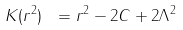Convert formula to latex. <formula><loc_0><loc_0><loc_500><loc_500>K ( r ^ { 2 } ) \ = r ^ { 2 } - 2 C + 2 \Lambda ^ { 2 }</formula> 